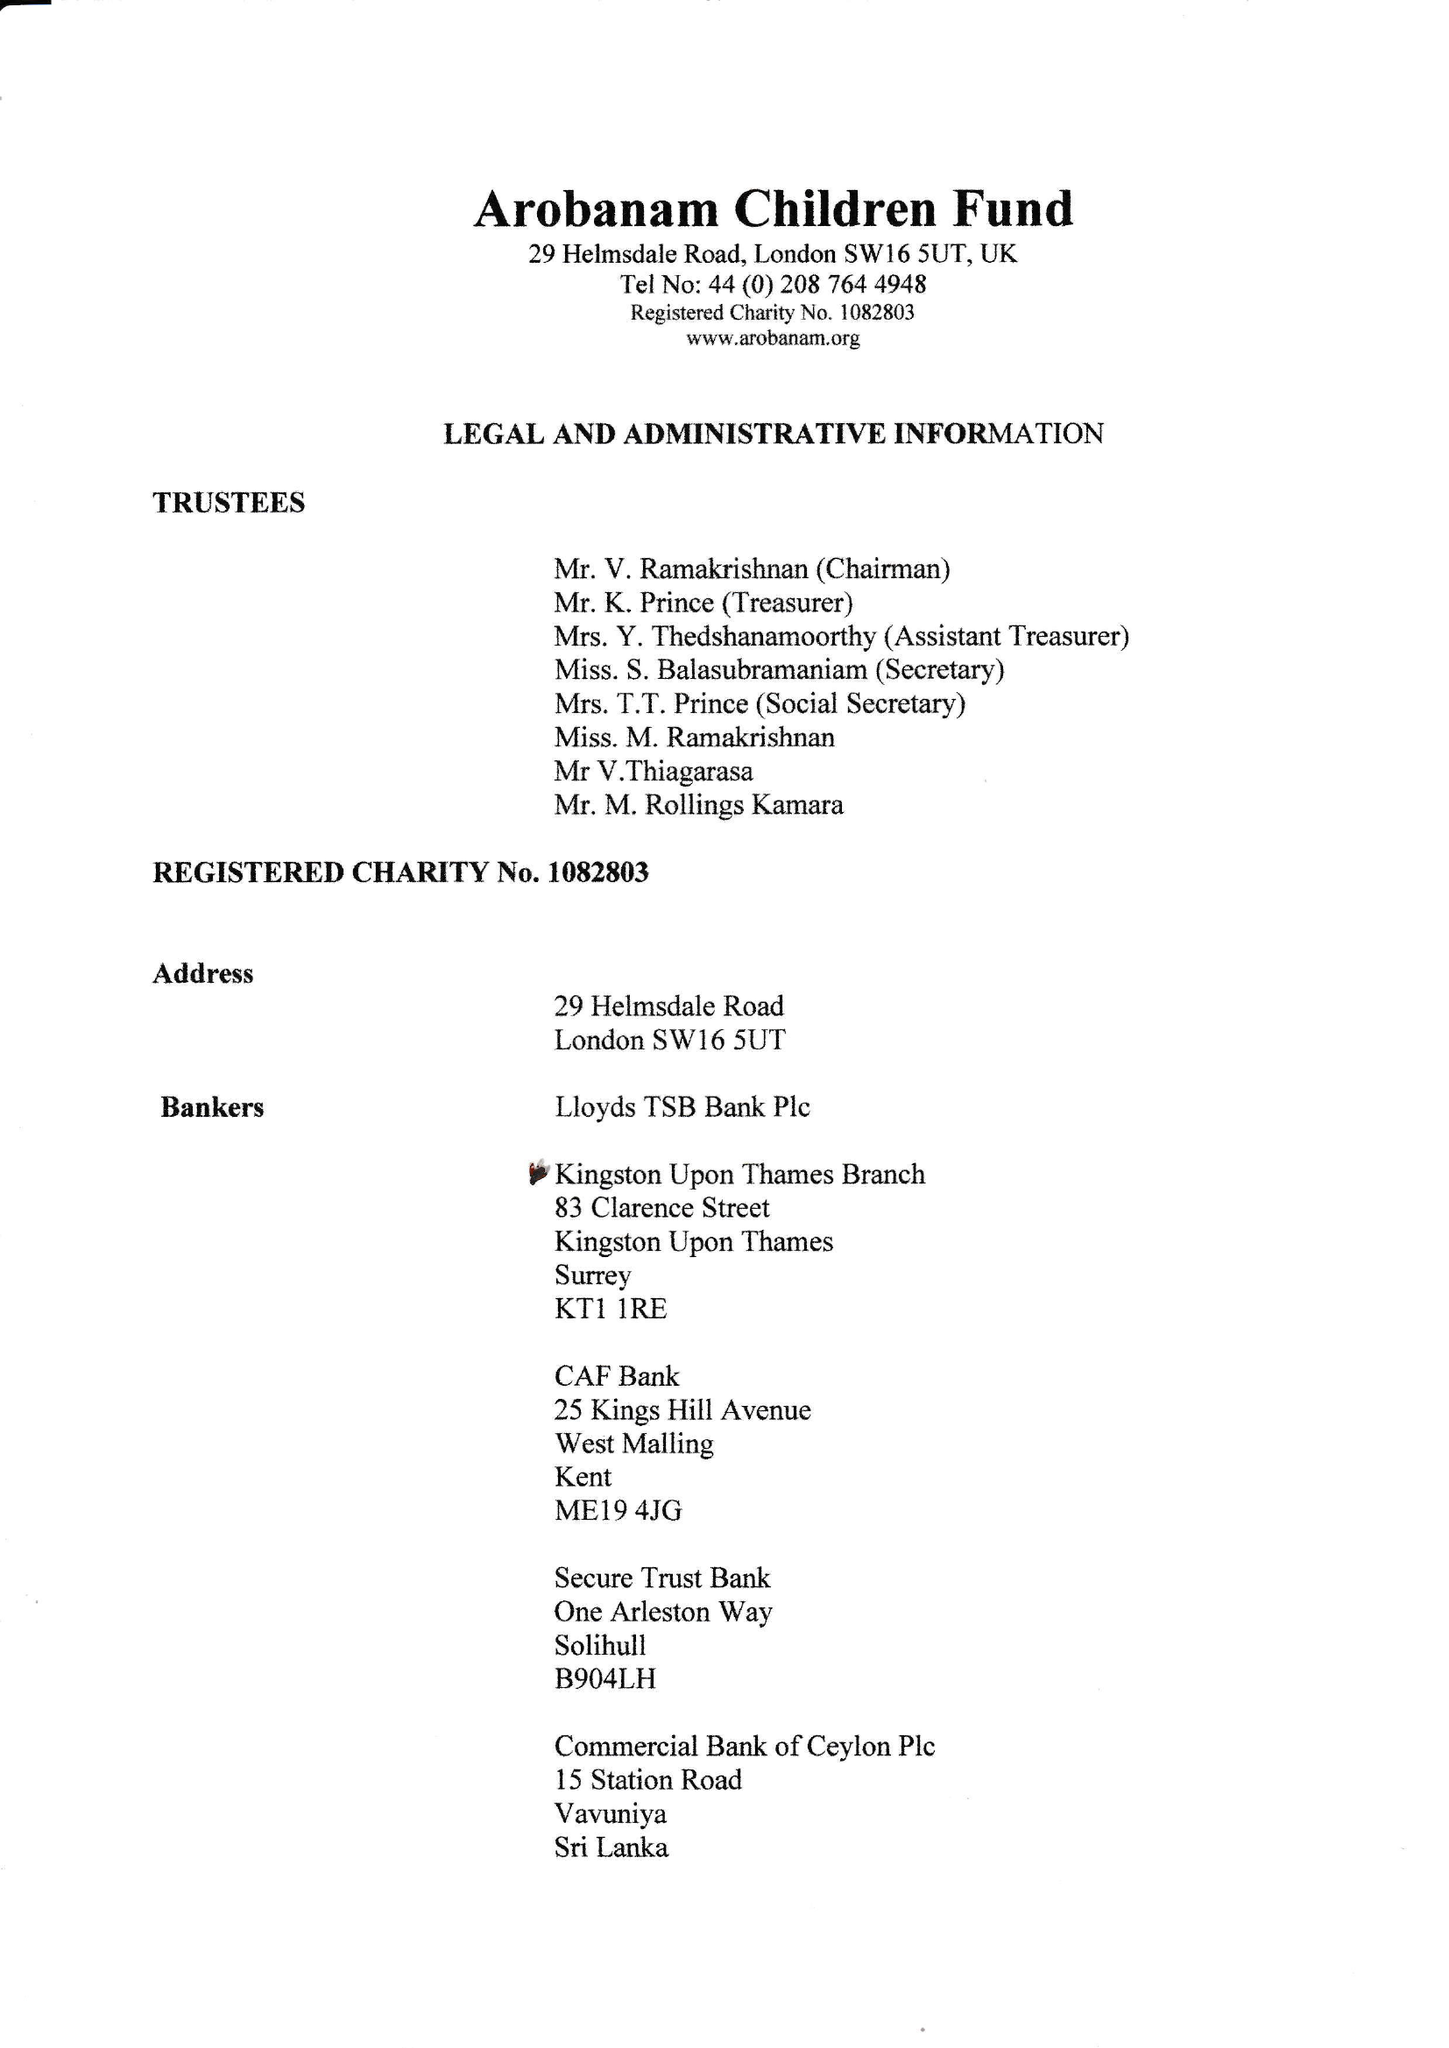What is the value for the spending_annually_in_british_pounds?
Answer the question using a single word or phrase. 92015.00 